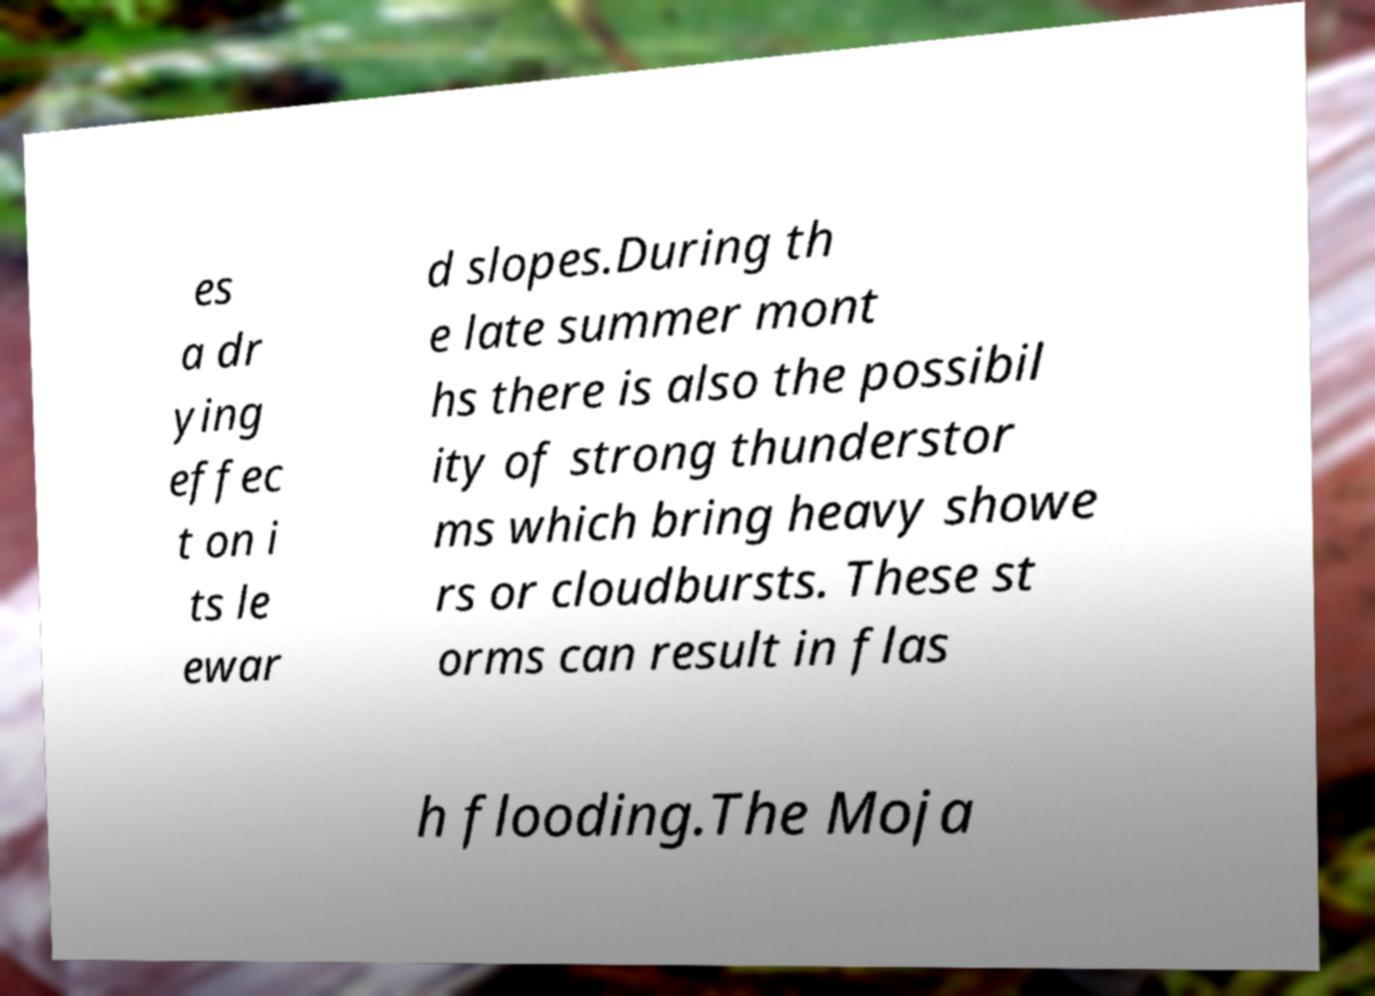I need the written content from this picture converted into text. Can you do that? es a dr ying effec t on i ts le ewar d slopes.During th e late summer mont hs there is also the possibil ity of strong thunderstor ms which bring heavy showe rs or cloudbursts. These st orms can result in flas h flooding.The Moja 